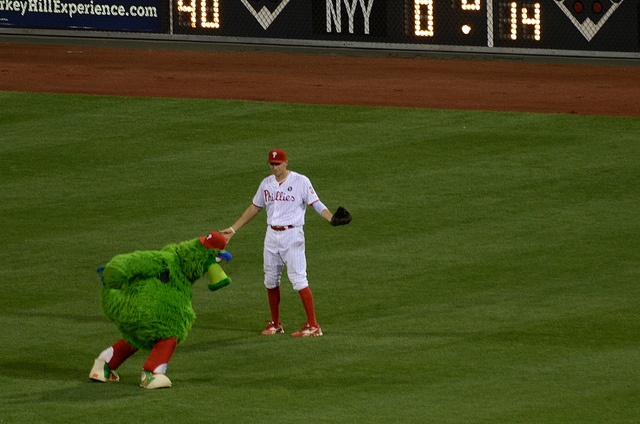Describe the objects in this image and their specific colors. I can see people in darkgreen, lavender, and darkgray tones and baseball glove in darkgreen and black tones in this image. 